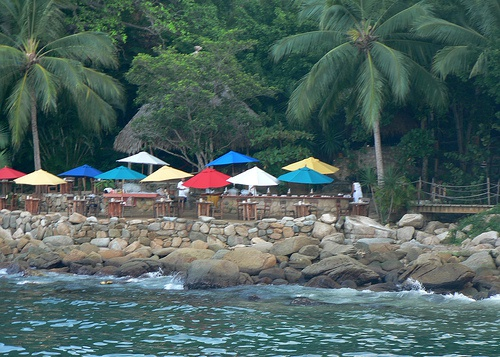Describe the objects in this image and their specific colors. I can see chair in teal, gray, and darkgray tones, umbrella in teal, lightyellow, black, khaki, and gray tones, umbrella in teal, white, gray, and darkgray tones, umbrella in teal, salmon, brown, and maroon tones, and umbrella in teal, lightblue, and darkgray tones in this image. 